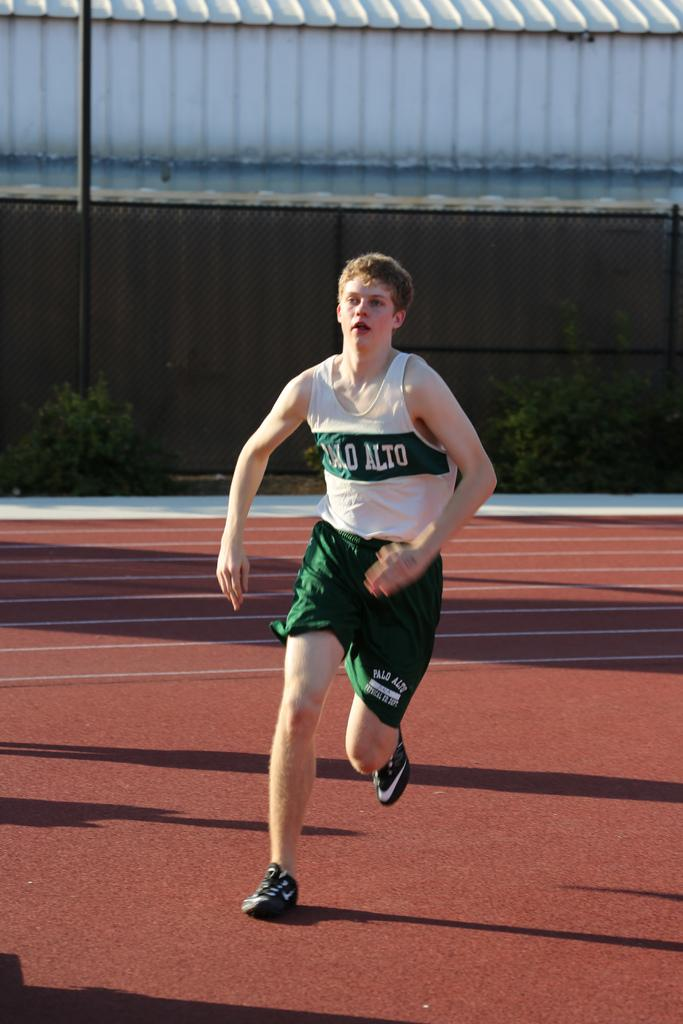<image>
Offer a succinct explanation of the picture presented. Student from Palo Alto wearing green and white clothes running on a track. 